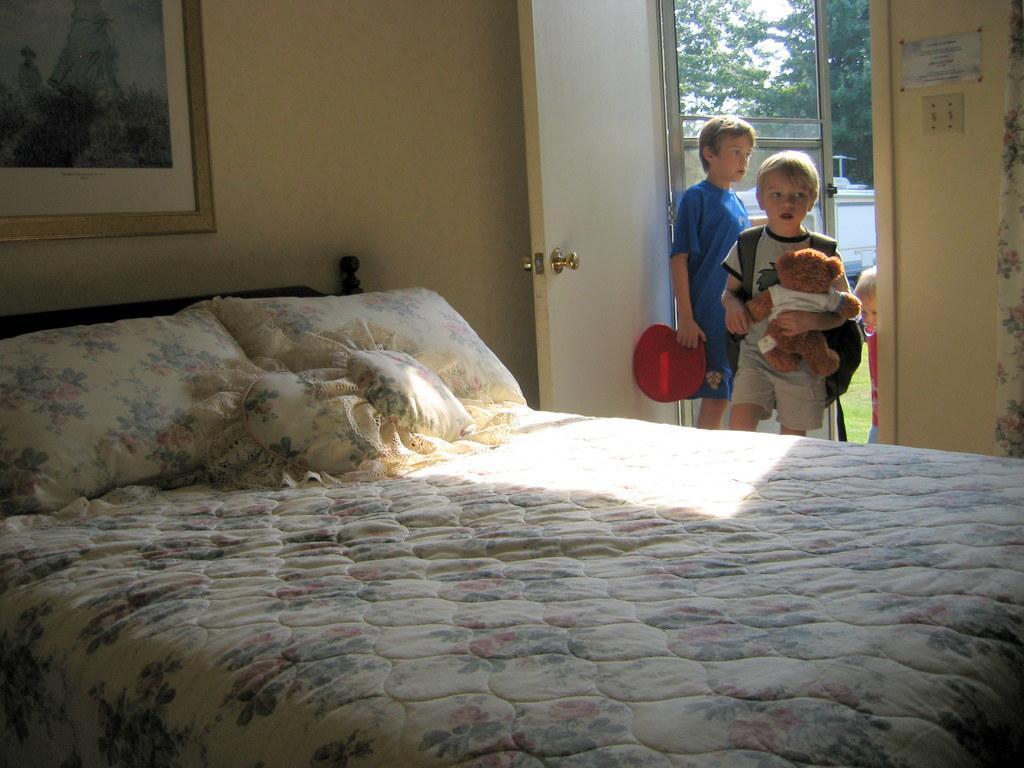Please provide a concise description of this image. Three people are entering to the room. In the room there is a bed,frame. Outside the room there are trees and sky. 